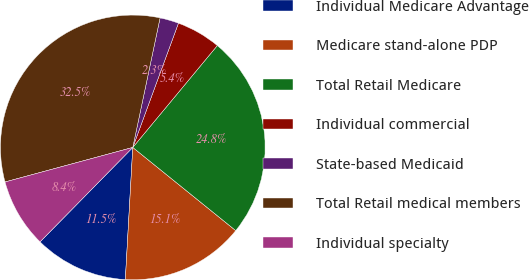Convert chart. <chart><loc_0><loc_0><loc_500><loc_500><pie_chart><fcel>Individual Medicare Advantage<fcel>Medicare stand-alone PDP<fcel>Total Retail Medicare<fcel>Individual commercial<fcel>State-based Medicaid<fcel>Total Retail medical members<fcel>Individual specialty<nl><fcel>11.46%<fcel>15.08%<fcel>24.79%<fcel>5.42%<fcel>2.3%<fcel>32.51%<fcel>8.44%<nl></chart> 